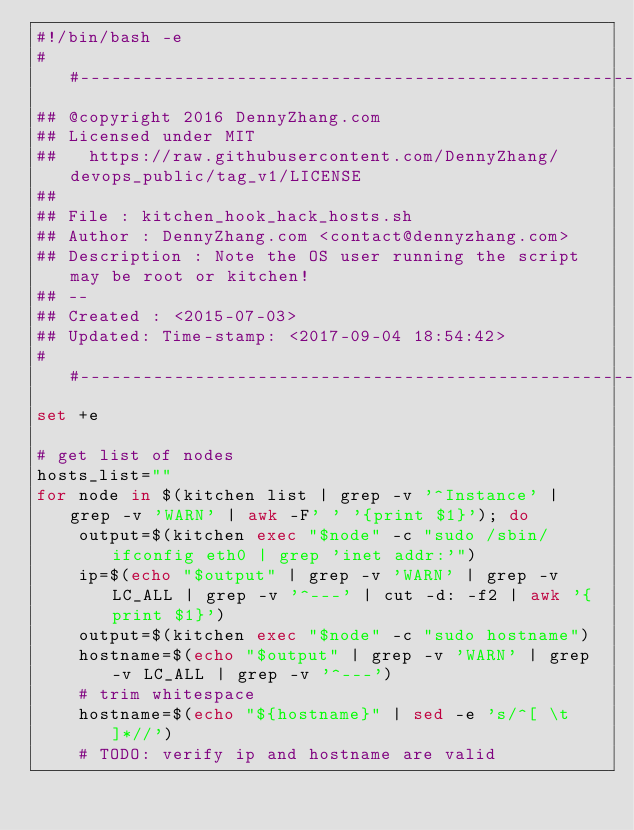<code> <loc_0><loc_0><loc_500><loc_500><_Bash_>#!/bin/bash -e
##-------------------------------------------------------------------
## @copyright 2016 DennyZhang.com
## Licensed under MIT
##   https://raw.githubusercontent.com/DennyZhang/devops_public/tag_v1/LICENSE
##
## File : kitchen_hook_hack_hosts.sh
## Author : DennyZhang.com <contact@dennyzhang.com>
## Description : Note the OS user running the script may be root or kitchen!
## --
## Created : <2015-07-03>
## Updated: Time-stamp: <2017-09-04 18:54:42>
##-------------------------------------------------------------------
set +e

# get list of nodes
hosts_list=""
for node in $(kitchen list | grep -v '^Instance' | grep -v 'WARN' | awk -F' ' '{print $1}'); do
    output=$(kitchen exec "$node" -c "sudo /sbin/ifconfig eth0 | grep 'inet addr:'")
    ip=$(echo "$output" | grep -v 'WARN' | grep -v LC_ALL | grep -v '^---' | cut -d: -f2 | awk '{print $1}')
    output=$(kitchen exec "$node" -c "sudo hostname")
    hostname=$(echo "$output" | grep -v 'WARN' | grep -v LC_ALL | grep -v '^---')
    # trim whitespace
    hostname=$(echo "${hostname}" | sed -e 's/^[ \t]*//')
    # TODO: verify ip and hostname are valid</code> 